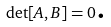Convert formula to latex. <formula><loc_0><loc_0><loc_500><loc_500>\det [ A , B ] = 0 \text {.}</formula> 